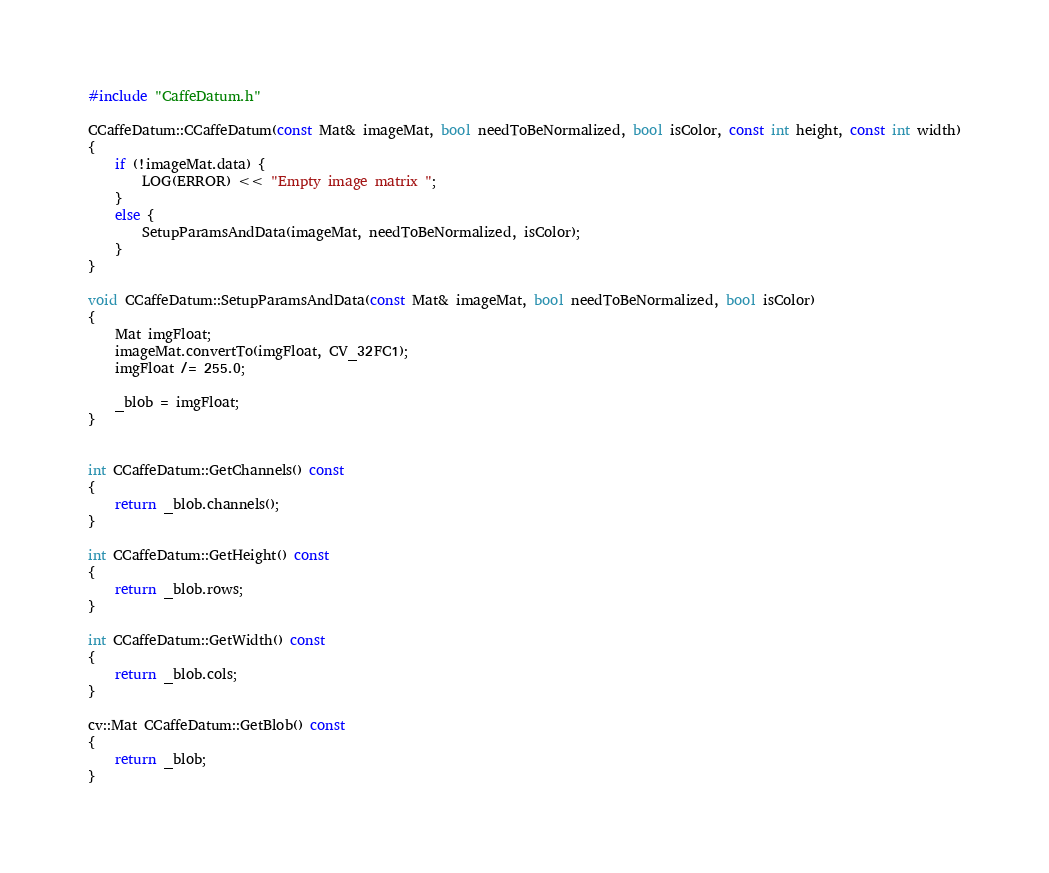Convert code to text. <code><loc_0><loc_0><loc_500><loc_500><_C++_>#include "CaffeDatum.h"

CCaffeDatum::CCaffeDatum(const Mat& imageMat, bool needToBeNormalized, bool isColor, const int height, const int width)
{
    if (!imageMat.data) {
        LOG(ERROR) << "Empty image matrix ";
    }
    else {
        SetupParamsAndData(imageMat, needToBeNormalized, isColor);
    }
}

void CCaffeDatum::SetupParamsAndData(const Mat& imageMat, bool needToBeNormalized, bool isColor)
{
    Mat imgFloat;
    imageMat.convertTo(imgFloat, CV_32FC1);
    imgFloat /= 255.0;

    _blob = imgFloat;
}


int CCaffeDatum::GetChannels() const
{
    return _blob.channels();
}

int CCaffeDatum::GetHeight() const
{
    return _blob.rows;
}

int CCaffeDatum::GetWidth() const
{
    return _blob.cols;
}

cv::Mat CCaffeDatum::GetBlob() const
{
    return _blob;
}
</code> 